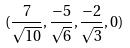Convert formula to latex. <formula><loc_0><loc_0><loc_500><loc_500>( \frac { 7 } { \sqrt { 1 0 } } , \frac { - 5 } { \sqrt { 6 } } , \frac { - 2 } { \sqrt { 3 } } , 0 )</formula> 